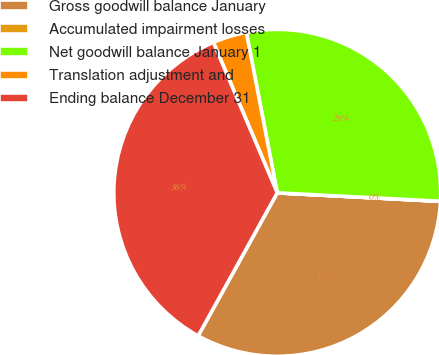Convert chart. <chart><loc_0><loc_0><loc_500><loc_500><pie_chart><fcel>Gross goodwill balance January<fcel>Accumulated impairment losses<fcel>Net goodwill balance January 1<fcel>Translation adjustment and<fcel>Ending balance December 31<nl><fcel>32.21%<fcel>0.01%<fcel>28.85%<fcel>3.36%<fcel>35.57%<nl></chart> 